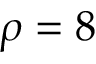Convert formula to latex. <formula><loc_0><loc_0><loc_500><loc_500>\rho = 8</formula> 